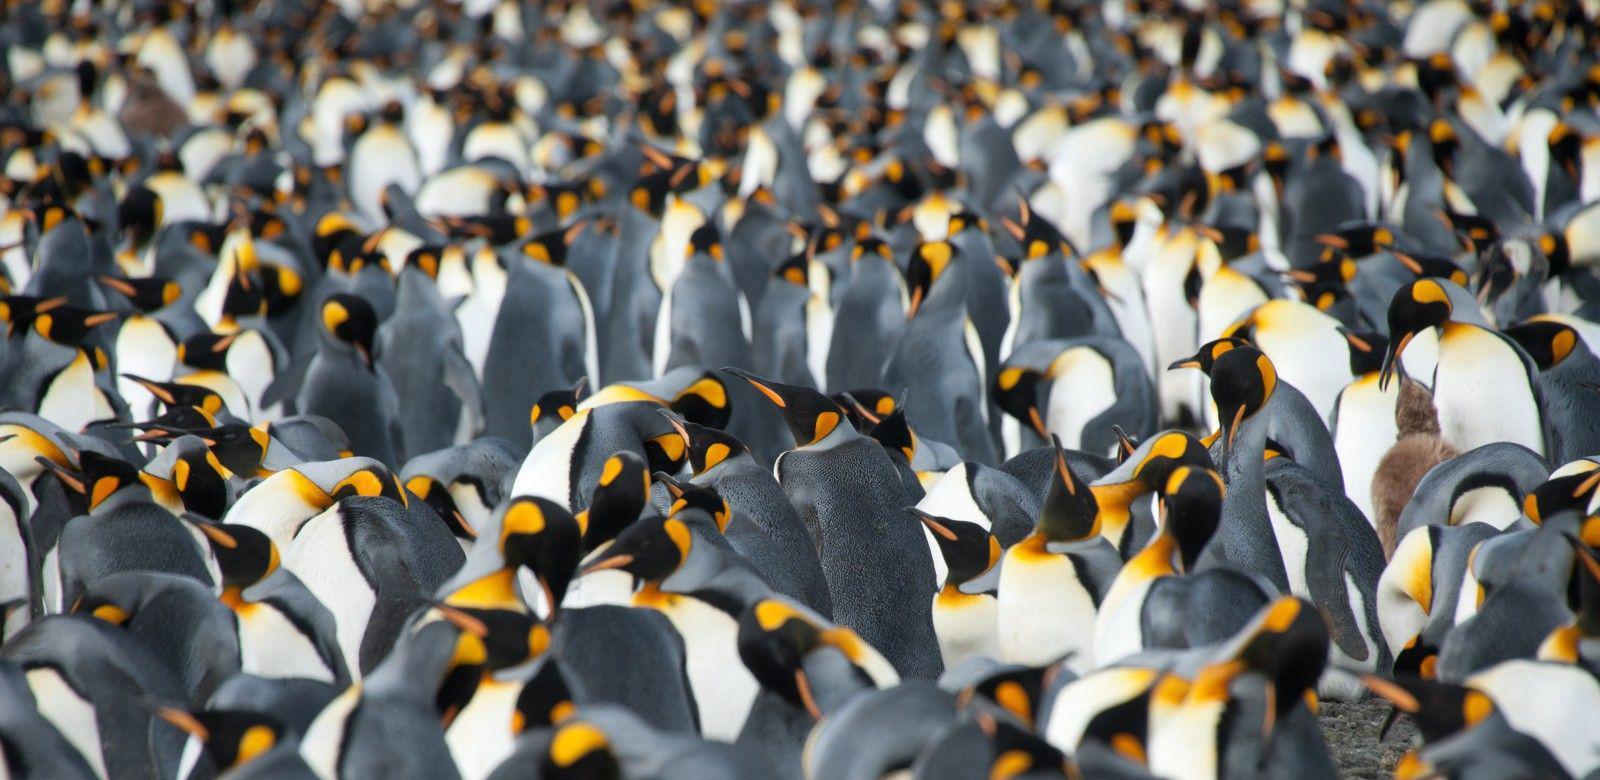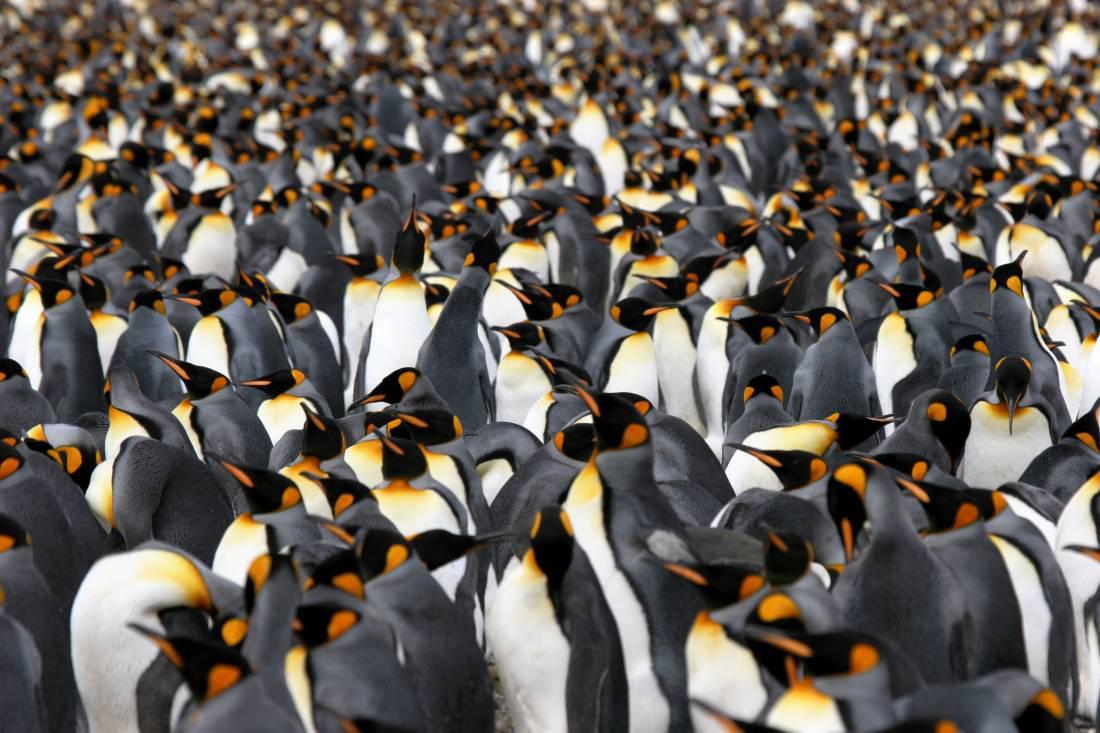The first image is the image on the left, the second image is the image on the right. Assess this claim about the two images: "The ground is visible in the image on the right.". Correct or not? Answer yes or no. No. 